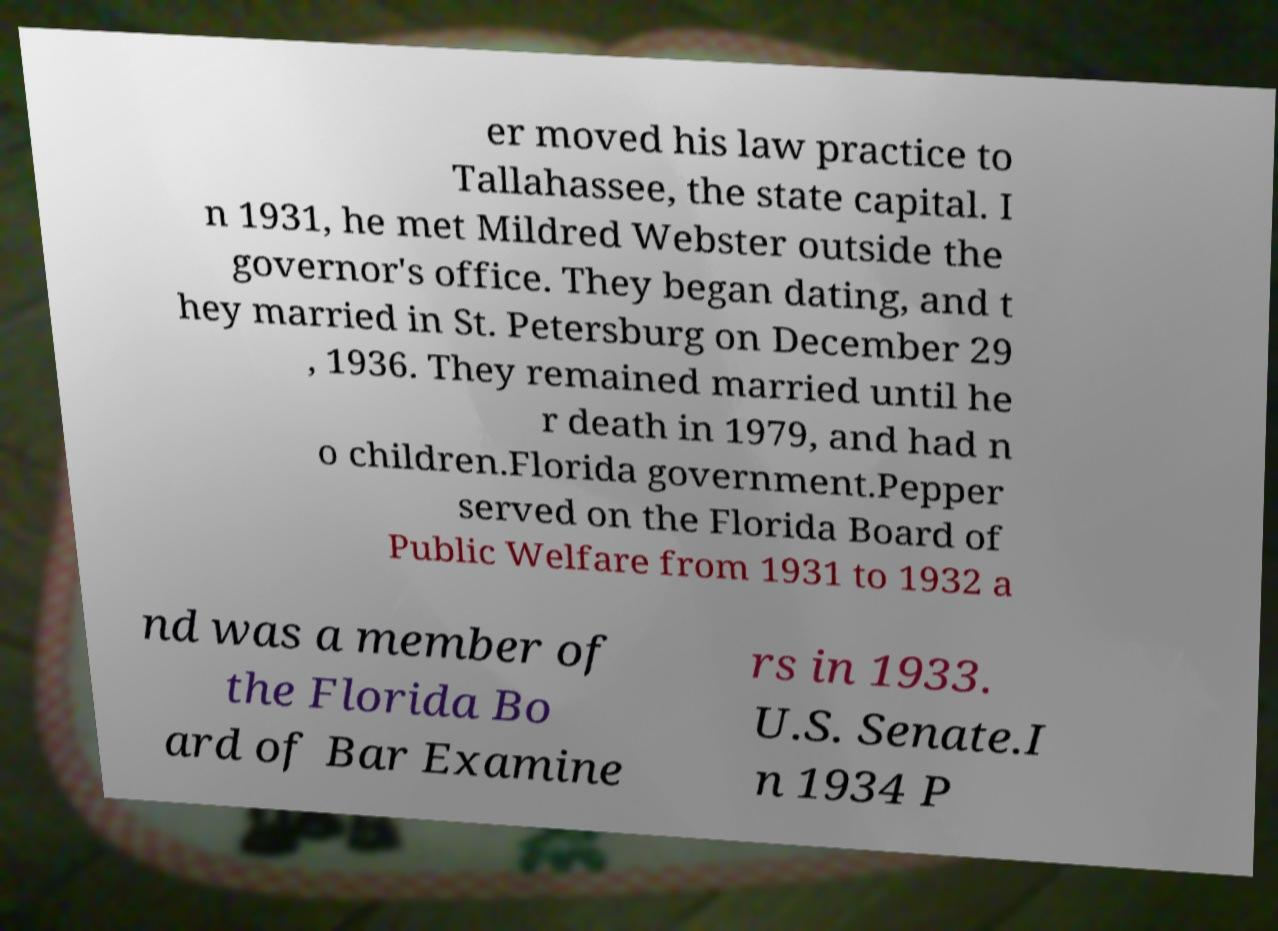Could you assist in decoding the text presented in this image and type it out clearly? er moved his law practice to Tallahassee, the state capital. I n 1931, he met Mildred Webster outside the governor's office. They began dating, and t hey married in St. Petersburg on December 29 , 1936. They remained married until he r death in 1979, and had n o children.Florida government.Pepper served on the Florida Board of Public Welfare from 1931 to 1932 a nd was a member of the Florida Bo ard of Bar Examine rs in 1933. U.S. Senate.I n 1934 P 